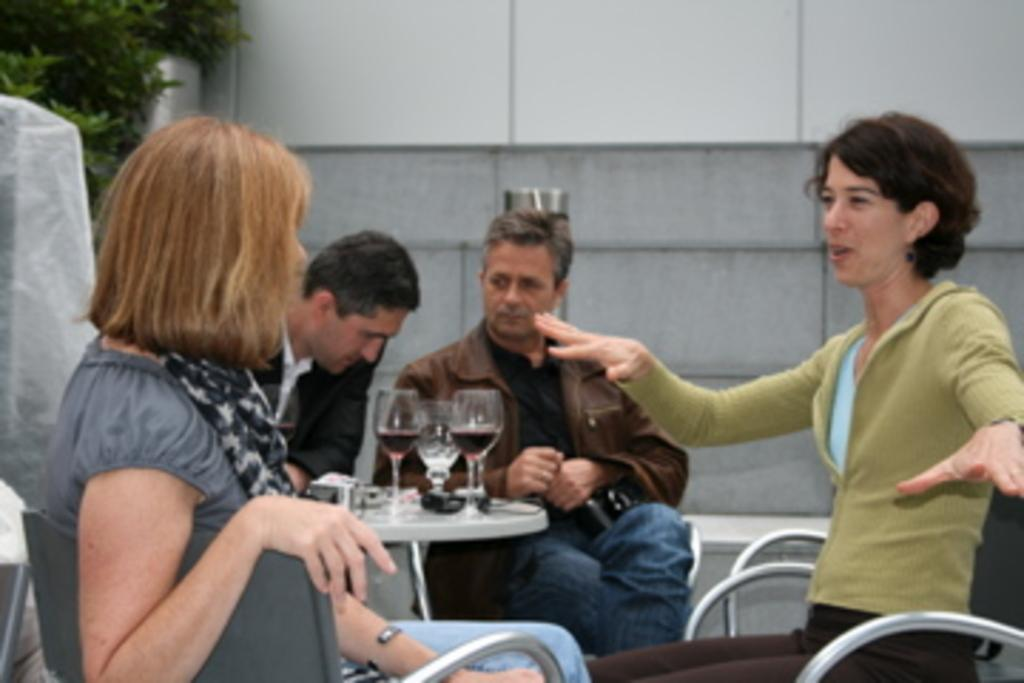How many people are sitting in the image? There are four people sitting on chairs in the image. What can be seen on the table in the image? There are glasses and other objects on the table in the image. What is visible in the background of the image? There is a wall and leaves in the background of the image. What type of chalk is being used by the people in the image? There is no chalk present in the image; the people are sitting on chairs and not using any chalk. Can you describe the insects flying around the people in the image? There are no insects visible in the image; the focus is on the people sitting on chairs and the objects on the table. 